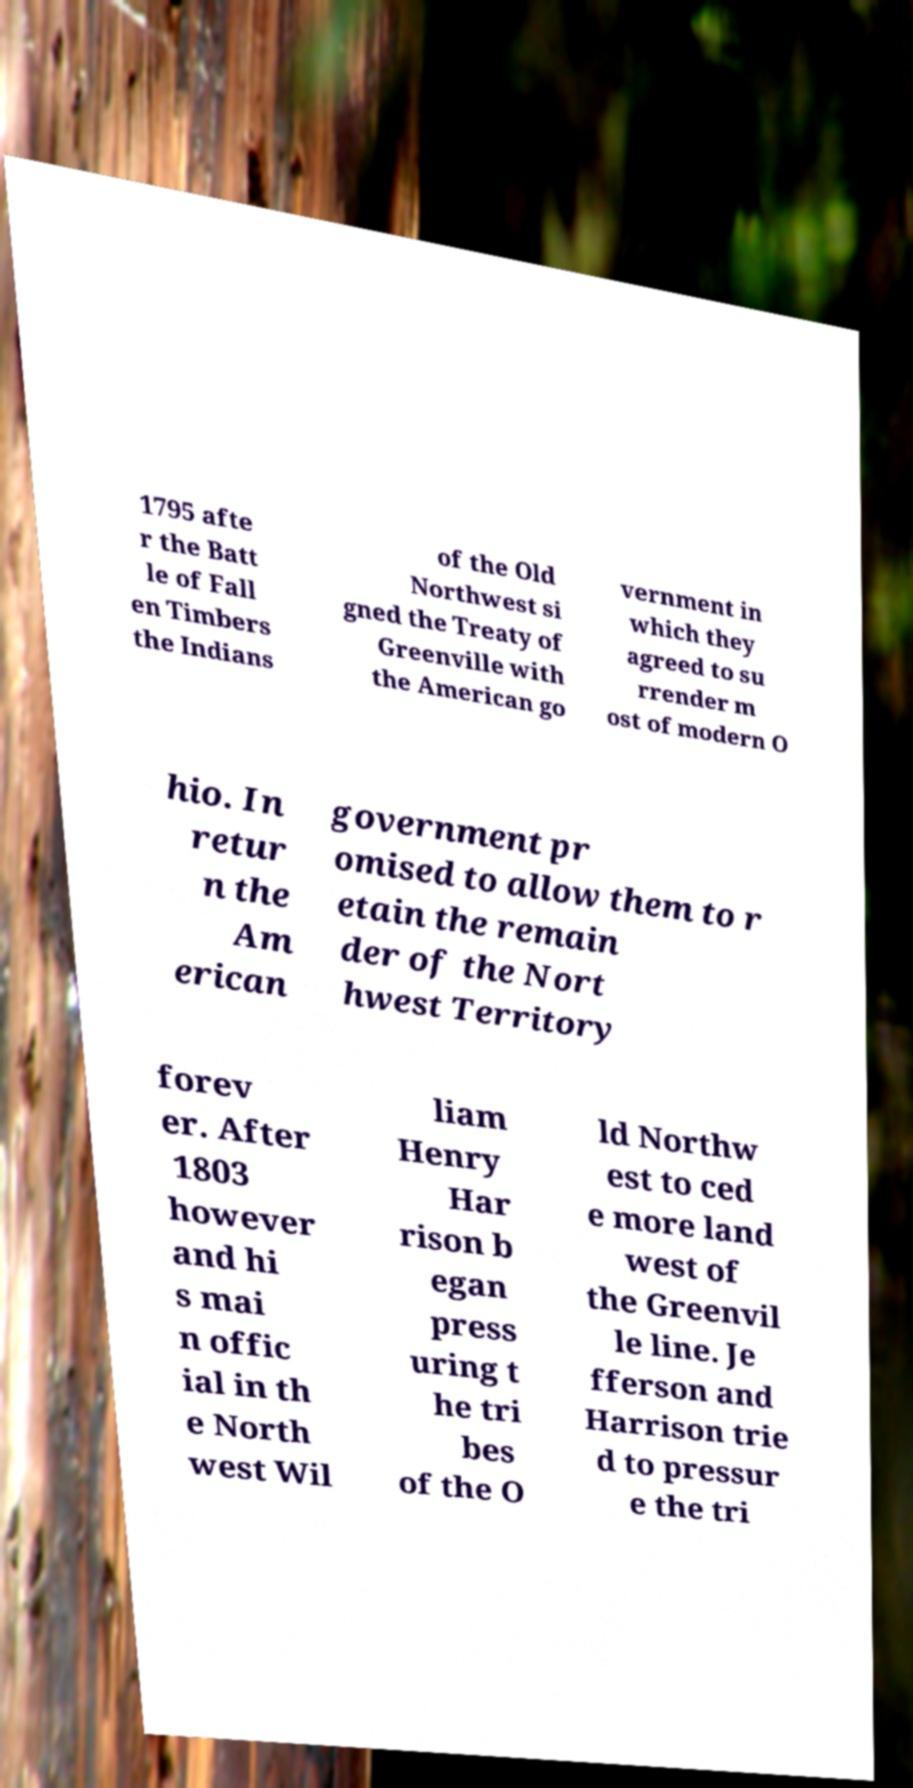Please identify and transcribe the text found in this image. 1795 afte r the Batt le of Fall en Timbers the Indians of the Old Northwest si gned the Treaty of Greenville with the American go vernment in which they agreed to su rrender m ost of modern O hio. In retur n the Am erican government pr omised to allow them to r etain the remain der of the Nort hwest Territory forev er. After 1803 however and hi s mai n offic ial in th e North west Wil liam Henry Har rison b egan press uring t he tri bes of the O ld Northw est to ced e more land west of the Greenvil le line. Je fferson and Harrison trie d to pressur e the tri 